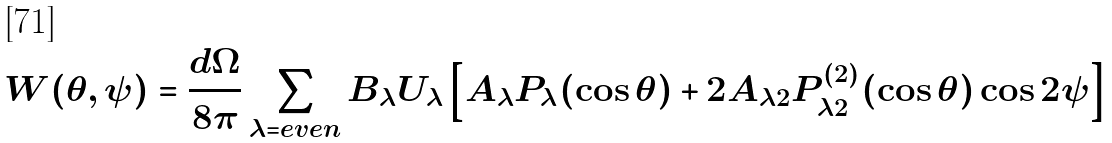<formula> <loc_0><loc_0><loc_500><loc_500>W ( \theta , \psi ) = \frac { d \Omega } { 8 \pi } \sum _ { \lambda = e v e n } B _ { \lambda } U _ { \lambda } \left [ A _ { \lambda } P _ { \lambda } ( \cos \theta ) + 2 A _ { \lambda 2 } P _ { \lambda 2 } ^ { ( 2 ) } ( \cos \theta ) \cos 2 \psi \right ]</formula> 